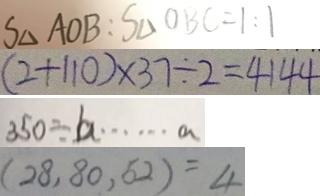Convert formula to latex. <formula><loc_0><loc_0><loc_500><loc_500>S _ { \Delta } A O B : S _ { \Delta } O B C = 1 : 1 
 ( 2 + 1 1 0 ) \times 3 7 \div 2 = 4 1 4 4 
 3 5 0 \div b \cdots a 
 ( 2 8 , 8 0 , 5 2 ) = 4</formula> 